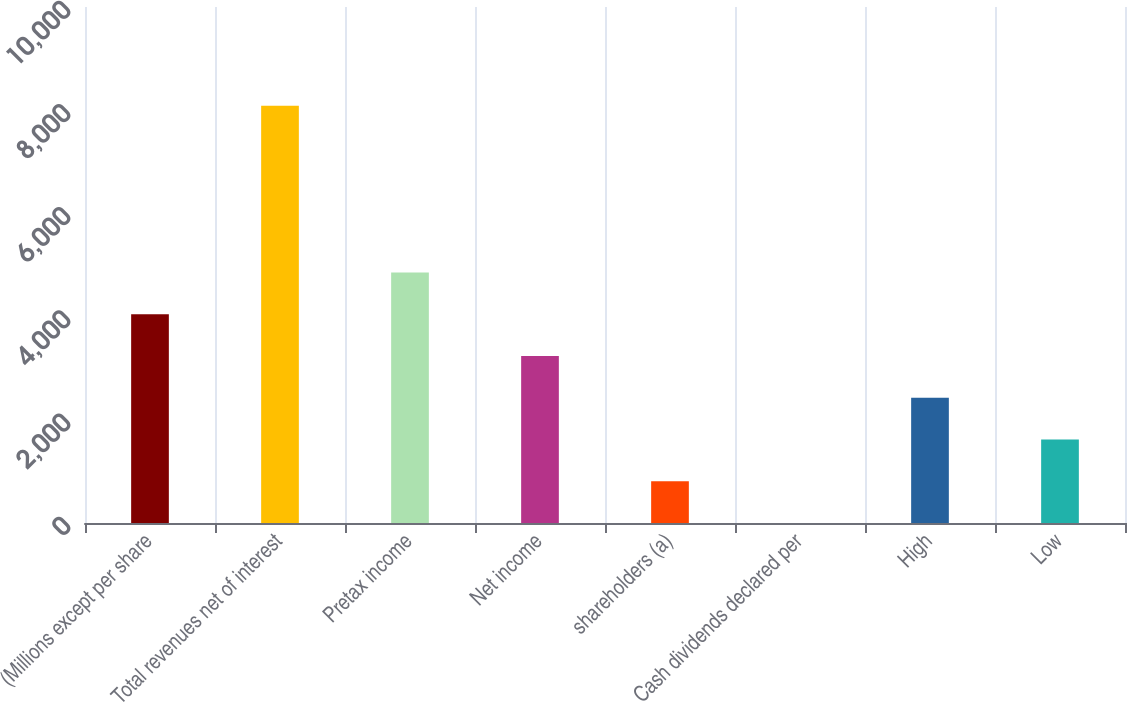<chart> <loc_0><loc_0><loc_500><loc_500><bar_chart><fcel>(Millions except per share<fcel>Total revenues net of interest<fcel>Pretax income<fcel>Net income<fcel>shareholders (a)<fcel>Cash dividends declared per<fcel>High<fcel>Low<nl><fcel>4044.14<fcel>8088<fcel>4852.91<fcel>3235.37<fcel>809.06<fcel>0.29<fcel>2426.6<fcel>1617.83<nl></chart> 